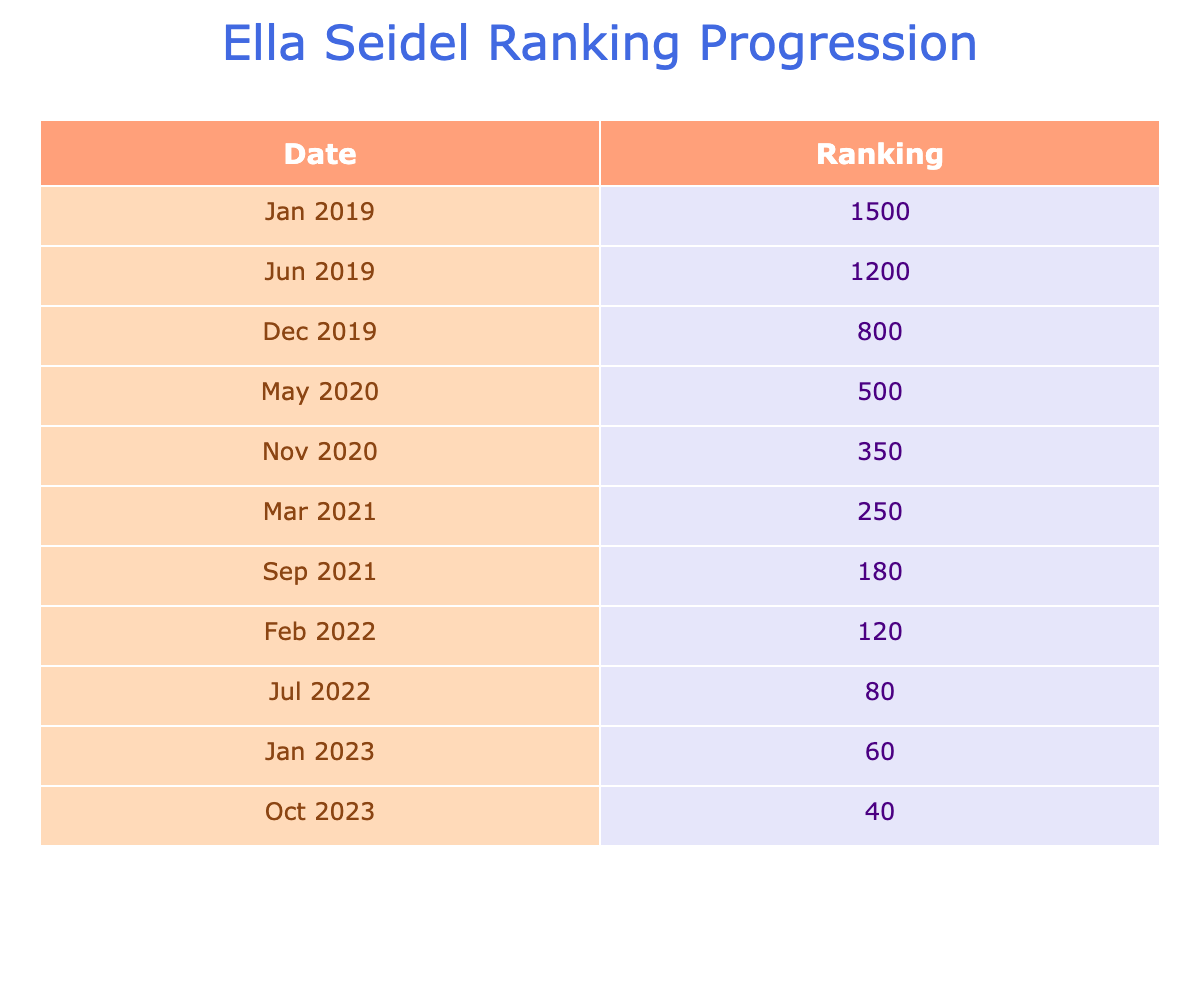What was Ella Seidel's ranking in June 2019? The table shows a specific entry for June 2019, where it states her ranking as 1200.
Answer: 1200 What was the highest ranking that Ella reached in the table data? From the rankings listed, the highest value noted is 1500 in January 2019.
Answer: 1500 In which month of 2022 did Ella achieve her best ranking? By examining the rankings in 2022, July shows a ranking of 80, which is the best for that year.
Answer: July How many total ranking entries are there in the table? The data contains a total of 11 entries, counting each monthly ranking from January 2019 to October 2023.
Answer: 11 What is the average ranking from 2019 to 2023? To find the average, sum all the rankings: 1500 + 1200 + 800 + 500 + 350 + 250 + 180 + 120 + 80 + 60 + 40 = 4080. Then divide by the number of entries (11): 4080 / 11 = 370.91, rounded to 371.
Answer: 371 Has Ella ever ranked below 100 between the years 2019 and 2023? Yes, in July 2022, her ranking reached as low as 80, indicating she was below 100 at that time.
Answer: Yes What was Ella Seidel's ranking progression trend from January 2021 to October 2023? Between January 2021 (ranking 250) and October 2023 (ranking 40), the trend shows a consistent improvement in ranking, as the values decrease steadily over time.
Answer: Consistently improving In what month did Ella make the most significant jump in her ranking between the years provided? Analyzing the data shows that from December 2019 (ranking 800) to May 2020 (ranking 500), the decrease of 300 is the largest leap within a single transition.
Answer: May 2020 Was there any month in 2020 where her ranking improved compared to the last recorded month of 2019? Yes, in May 2020, her ranking improved from 800 in December 2019 to 500 in May 2020.
Answer: Yes 